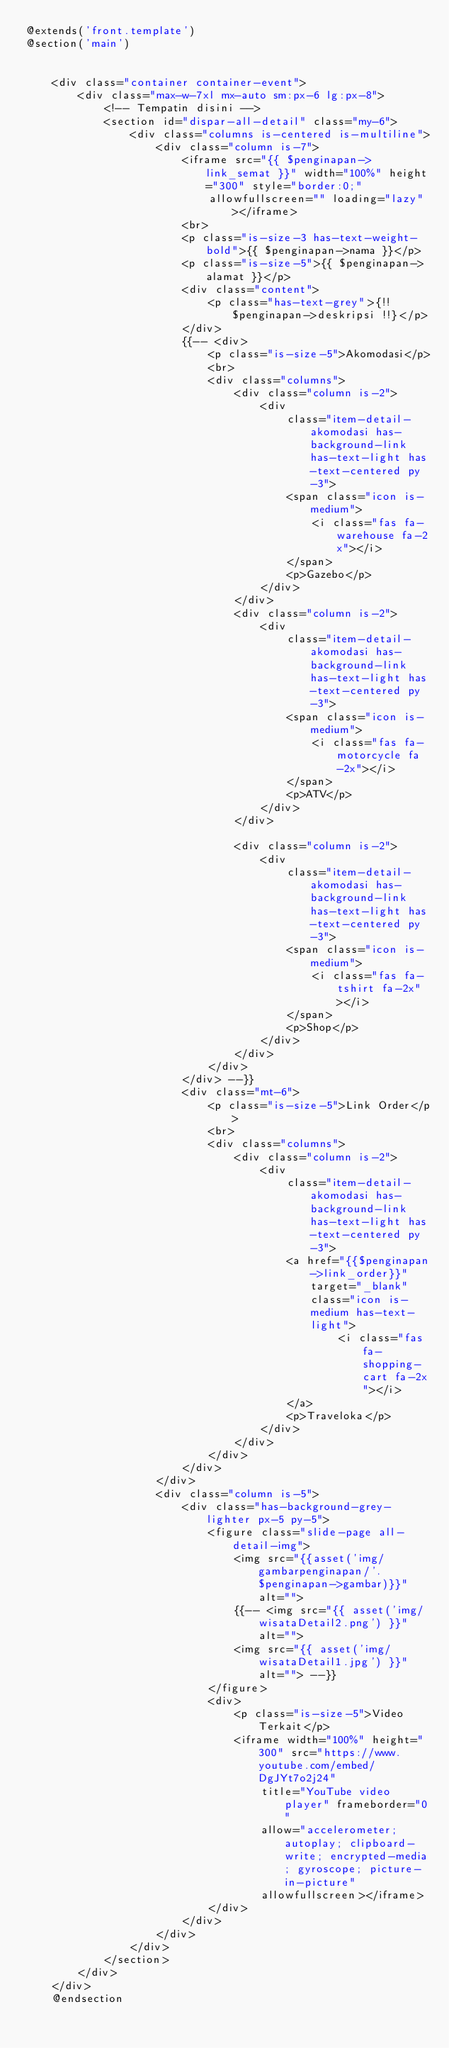Convert code to text. <code><loc_0><loc_0><loc_500><loc_500><_PHP_>@extends('front.template')
@section('main')


    <div class="container container-event">
        <div class="max-w-7xl mx-auto sm:px-6 lg:px-8">
            <!-- Tempatin disini -->
            <section id="dispar-all-detail" class="my-6">
                <div class="columns is-centered is-multiline">
                    <div class="column is-7">
                        <iframe src="{{ $penginapan->link_semat }}" width="100%" height="300" style="border:0;"
                            allowfullscreen="" loading="lazy"></iframe>
                        <br>
                        <p class="is-size-3 has-text-weight-bold">{{ $penginapan->nama }}</p>
                        <p class="is-size-5">{{ $penginapan->alamat }}</p>
                        <div class="content">
                            <p class="has-text-grey">{!! $penginapan->deskripsi !!}</p>
                        </div>
                        {{-- <div>
                            <p class="is-size-5">Akomodasi</p>
                            <br>
                            <div class="columns">
                                <div class="column is-2">
                                    <div
                                        class="item-detail-akomodasi has-background-link has-text-light has-text-centered py-3">
                                        <span class="icon is-medium">
                                            <i class="fas fa-warehouse fa-2x"></i>
                                        </span>
                                        <p>Gazebo</p>
                                    </div>
                                </div>
                                <div class="column is-2">
                                    <div
                                        class="item-detail-akomodasi has-background-link has-text-light has-text-centered py-3">
                                        <span class="icon is-medium">
                                            <i class="fas fa-motorcycle fa-2x"></i>
                                        </span>
                                        <p>ATV</p>
                                    </div>
                                </div>

                                <div class="column is-2">
                                    <div
                                        class="item-detail-akomodasi has-background-link has-text-light has-text-centered py-3">
                                        <span class="icon is-medium">
                                            <i class="fas fa-tshirt fa-2x"></i>
                                        </span>
                                        <p>Shop</p>
                                    </div>
                                </div>
                            </div>
                        </div> --}}
                        <div class="mt-6">
                            <p class="is-size-5">Link Order</p>
                            <br>
                            <div class="columns">
                                <div class="column is-2">
                                    <div
                                        class="item-detail-akomodasi has-background-link has-text-light has-text-centered py-3">
                                        <a href="{{$penginapan->link_order}}" target="_blank" class="icon is-medium has-text-light">
                                                <i class="fas fa-shopping-cart fa-2x"></i>
                                        </a>
                                        <p>Traveloka</p>
                                    </div>
                                </div>
                            </div>
                        </div>
                    </div>
                    <div class="column is-5">
                        <div class="has-background-grey-lighter px-5 py-5">
                            <figure class="slide-page all-detail-img">
                                <img src="{{asset('img/gambarpenginapan/'.$penginapan->gambar)}}" alt="">
                                {{-- <img src="{{ asset('img/wisataDetail2.png') }}" alt="">
                                <img src="{{ asset('img/wisataDetail1.jpg') }}" alt=""> --}}
                            </figure>
                            <div>
                                <p class="is-size-5">Video Terkait</p>
                                <iframe width="100%" height="300" src="https://www.youtube.com/embed/DgJYt7o2j24"
                                    title="YouTube video player" frameborder="0"
                                    allow="accelerometer; autoplay; clipboard-write; encrypted-media; gyroscope; picture-in-picture"
                                    allowfullscreen></iframe>
                            </div>
                        </div>
                    </div>
                </div>
            </section>
        </div>
    </div>
    @endsection


</code> 